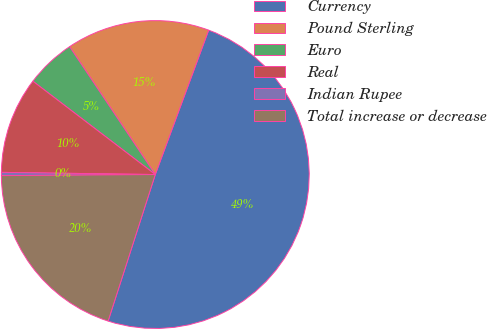Convert chart. <chart><loc_0><loc_0><loc_500><loc_500><pie_chart><fcel>Currency<fcel>Pound Sterling<fcel>Euro<fcel>Real<fcel>Indian Rupee<fcel>Total increase or decrease<nl><fcel>49.32%<fcel>15.03%<fcel>5.24%<fcel>10.14%<fcel>0.34%<fcel>19.93%<nl></chart> 